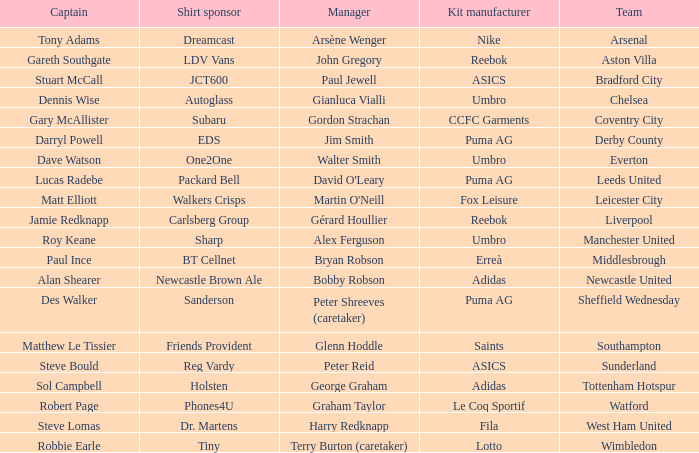Which shirt sponser has Nike as a kit manufacturer? Dreamcast. 